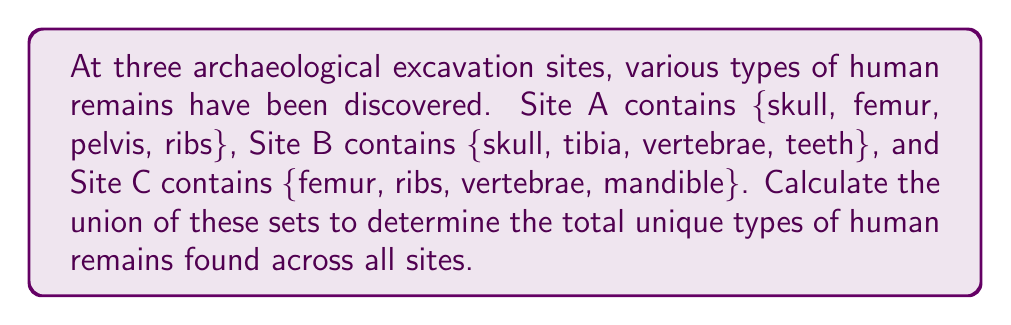Show me your answer to this math problem. To solve this problem, we need to find the union of the three sets representing the types of human remains found at each site. Let's denote the sets as follows:

$A = \{skull, femur, pelvis, ribs\}$
$B = \{skull, tibia, vertebrae, teeth\}$
$C = \{femur, ribs, vertebrae, mandible\}$

The union of these sets, denoted as $A \cup B \cup C$, will include all unique elements from all three sets. To calculate this:

1. Start with set A: $\{skull, femur, pelvis, ribs\}$
2. Add unique elements from set B:
   - $skull$ is already included
   - Add $tibia, vertebrae, teeth$
3. Add unique elements from set C:
   - $femur$ and $ribs$ are already included
   - $vertebrae$ is already added from set B
   - Add $mandible$

Therefore, the union of all three sets is:

$A \cup B \cup C = \{skull, femur, pelvis, ribs, tibia, vertebrae, teeth, mandible\}$

To verify, we can count the unique elements: there are 8 distinct types of human remains in the union.
Answer: $A \cup B \cup C = \{skull, femur, pelvis, ribs, tibia, vertebrae, teeth, mandible\}$ 